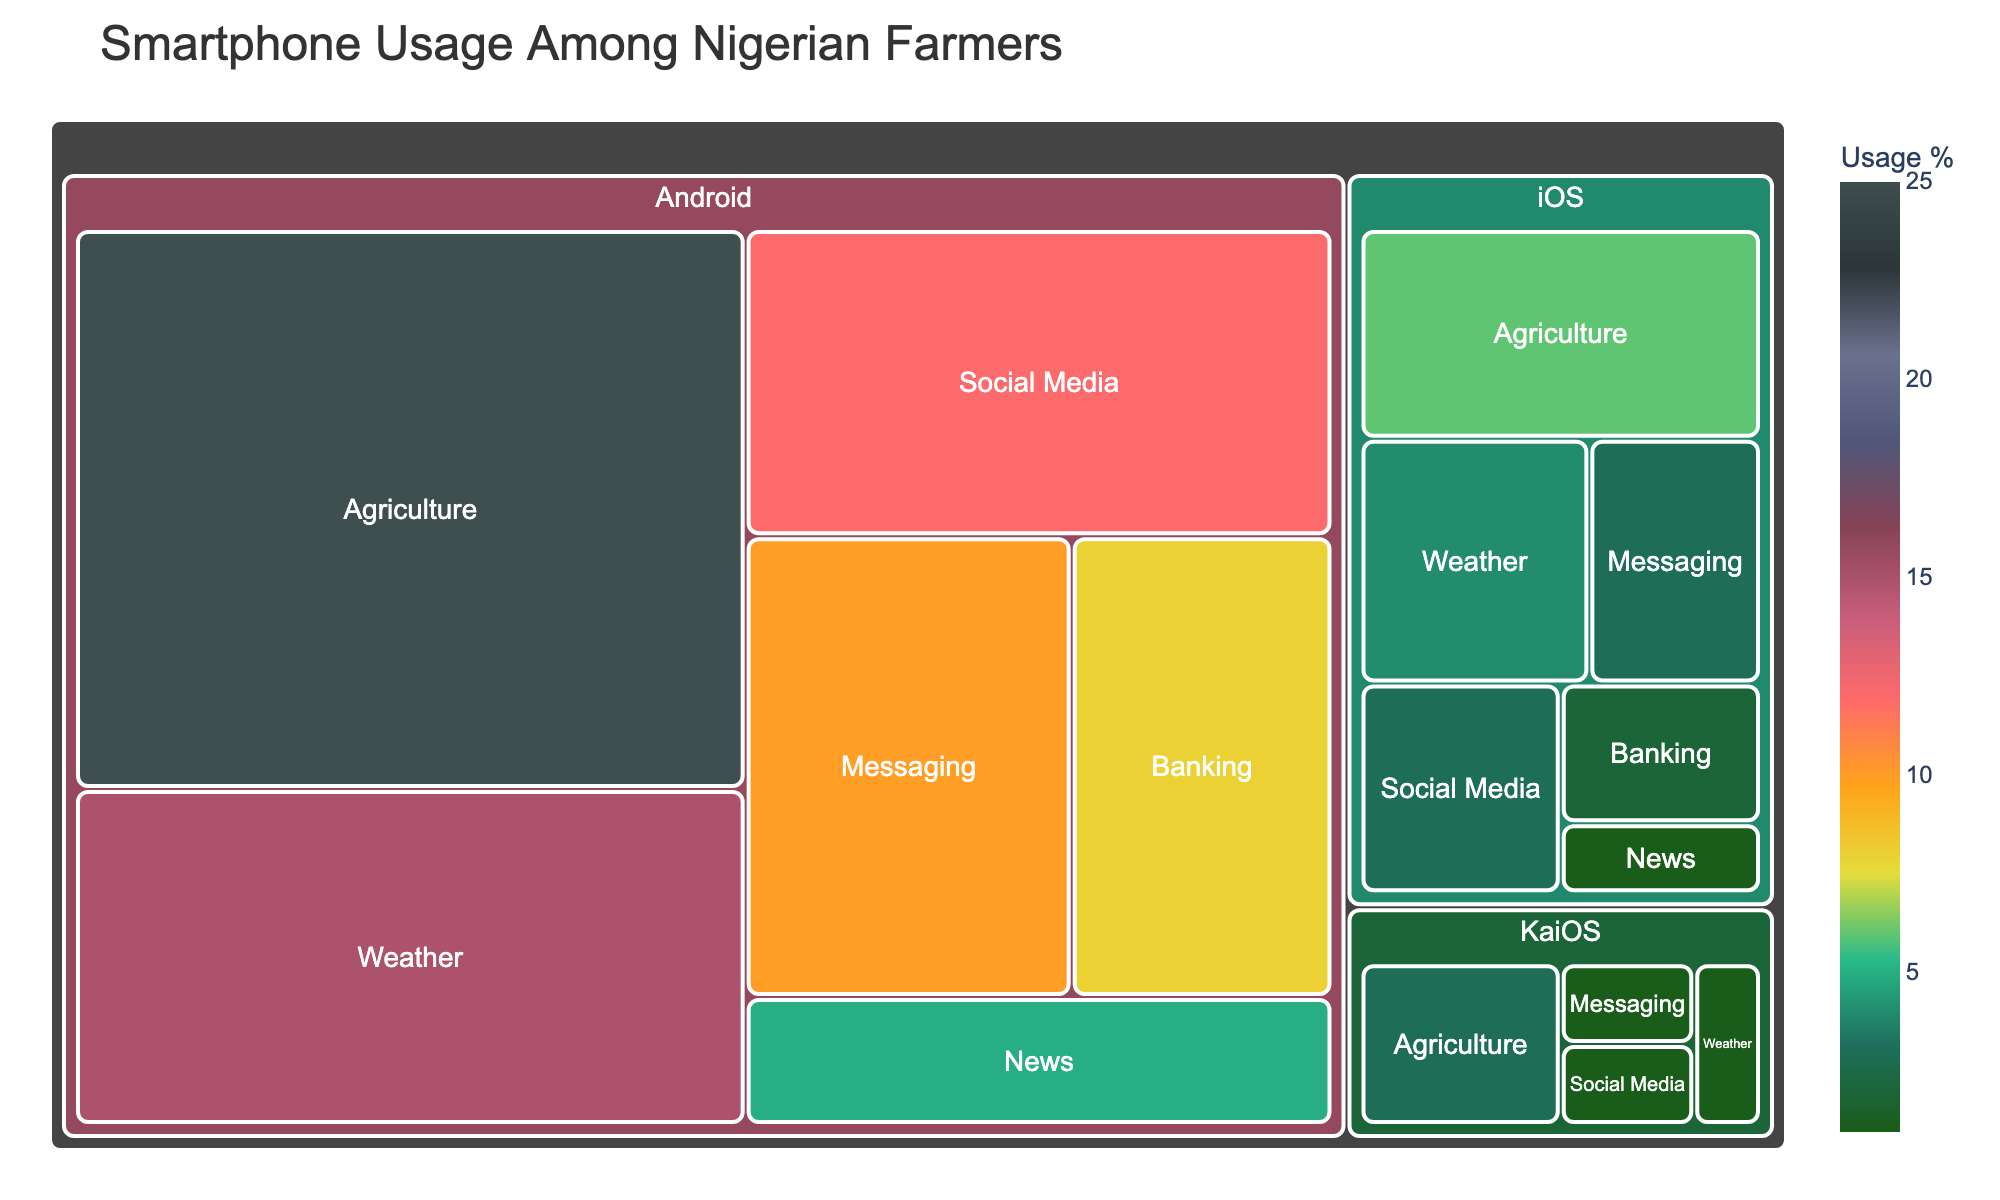What's the title of the figure? The title is located at the top of the figure and provides a concise summary of the visualized data.
Answer: Smartphone Usage Among Nigerian Farmers What are the three operating systems represented in the treemap? Identify the labels along the first level of the hierarchy.
Answer: Android, iOS, KaiOS Which app category has the highest usage percentage among Nigerian farmers using Android? Look for the largest section under the Android category.
Answer: Agriculture What is the total usage percentage for the Agriculture app category across all operating systems? Add the usage percentages for Agriculture under each operating system: Android (25) + iOS (6) + KaiOS (3).
Answer: 34% How does the usage percentage for Weather apps on Android compare to the same category on iOS? Compare the usage percentage values for Weather apps under both operating systems: Android (15%) and iOS (4%).
Answer: Weather apps on Android are used more than on iOS Which operating system shows the least usage for Social Media apps? Compare the Social Media usage percentages across Android, iOS, and KaiOS.
Answer: KaiOS What is the combined usage percentage of Messaging apps across all operating systems? Sum the usage percentages for Messaging in Android, iOS, and KaiOS: Android (10%) + iOS (3%) + KaiOS (1%).
Answer: 14% Is the usage percentage of Banking apps higher on Android or iOS? Compare the usage percentages of Banking apps on Android (8%) and iOS (2%).
Answer: Android How do the total usage percentages compare between Messaging and Banking app categories on Android? Sum the numbers individually for Messaging (10%) and Banking (8%) and compare them.
Answer: Messaging has a higher usage percentage Which app category has the least usage percentage on iOS? Identify the smallest percentage value among the iOS app categories.
Answer: News 